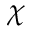Convert formula to latex. <formula><loc_0><loc_0><loc_500><loc_500>\chi</formula> 